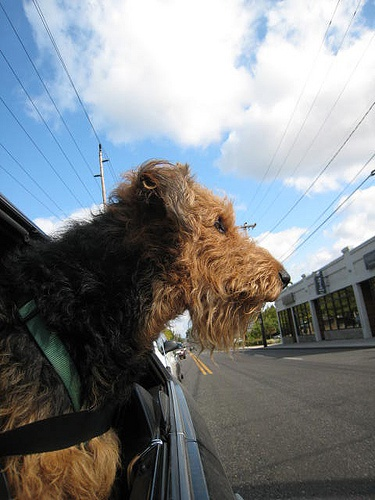Describe the objects in this image and their specific colors. I can see dog in gray, black, and maroon tones and car in gray, black, darkgray, and blue tones in this image. 